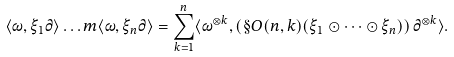<formula> <loc_0><loc_0><loc_500><loc_500>\langle \omega , \xi _ { 1 } \partial \rangle \dots m \langle \omega , \xi _ { n } \partial \rangle = \sum _ { k = 1 } ^ { n } \langle \omega ^ { \otimes k } , \left ( \S O ( n , k ) ( \xi _ { 1 } \odot \dots \odot \xi _ { n } ) \right ) \partial ^ { \otimes k } \rangle .</formula> 